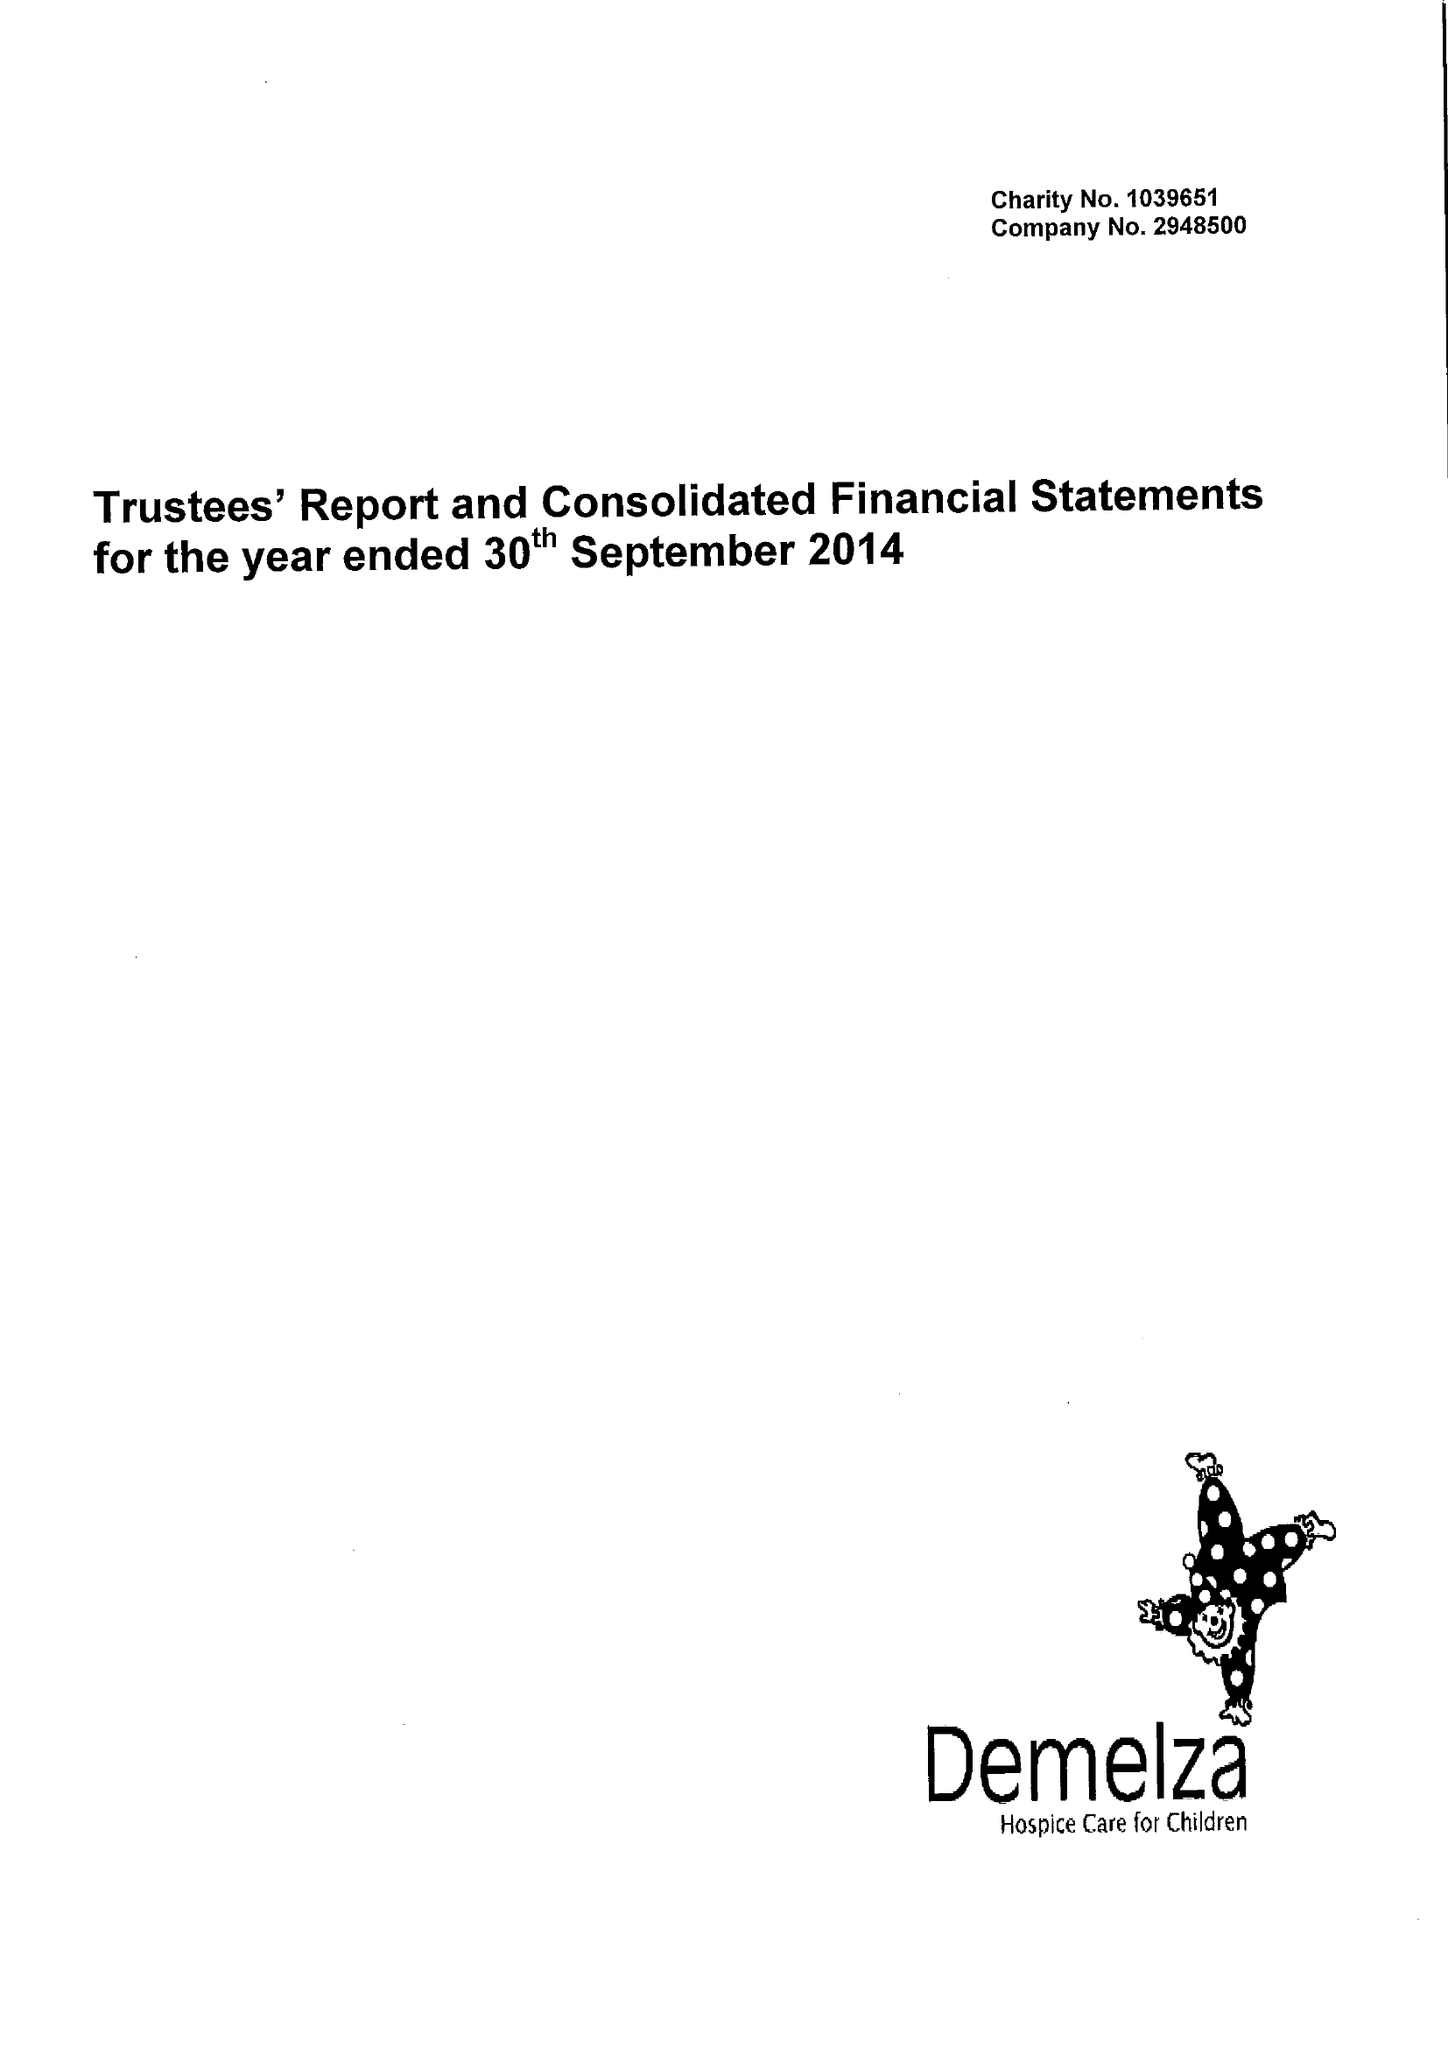What is the value for the charity_name?
Answer the question using a single word or phrase. Demelza House Childrens Hospice 